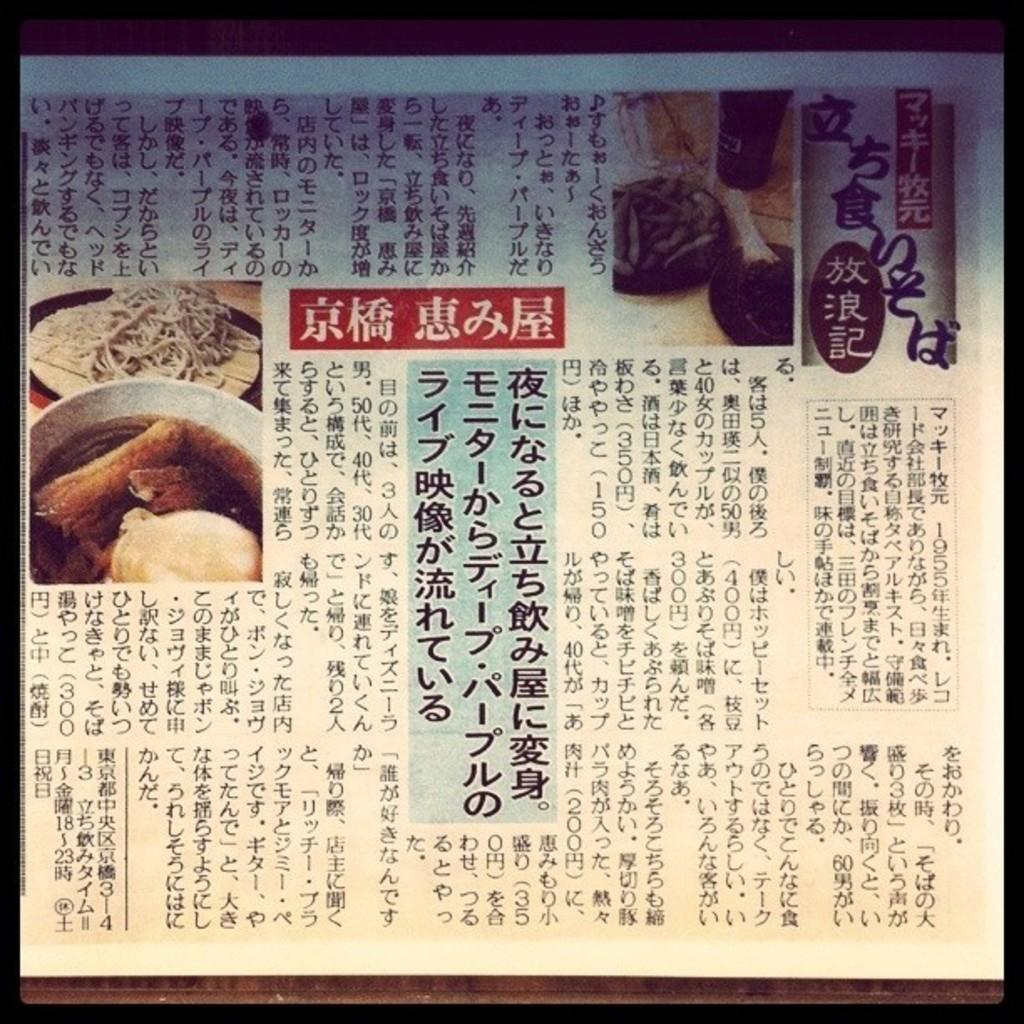What is present in the image that contains visual information? There is a poster in the image that contains images. What else can be found on the poster besides images? The poster contains text as well. What type of shirt is being worn by the person in the image? There is no person present in the image, only a poster with images and text. Is there any furniture visible in the image? There is no furniture visible in the image; it only contains a poster. 